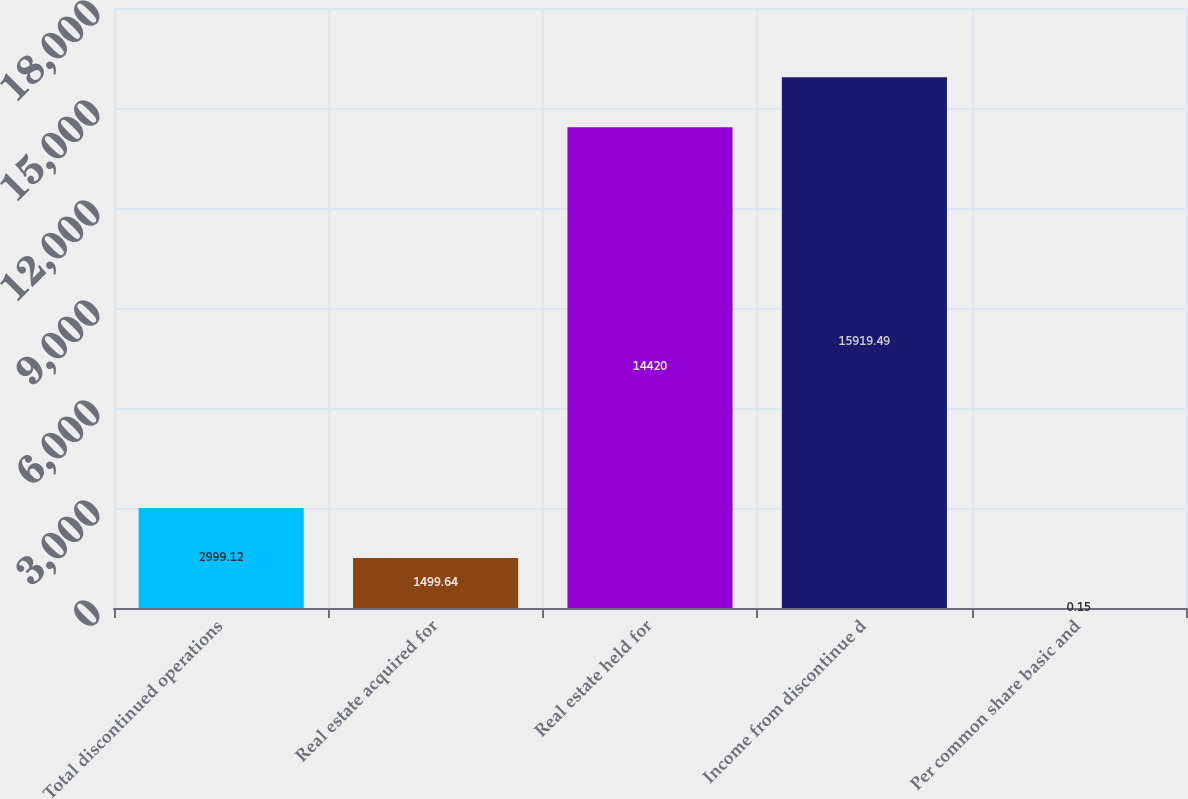Convert chart. <chart><loc_0><loc_0><loc_500><loc_500><bar_chart><fcel>Total discontinued operations<fcel>Real estate acquired for<fcel>Real estate held for<fcel>Income from discontinue d<fcel>Per common share basic and<nl><fcel>2999.12<fcel>1499.64<fcel>14420<fcel>15919.5<fcel>0.15<nl></chart> 